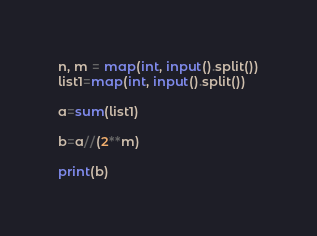<code> <loc_0><loc_0><loc_500><loc_500><_Python_>n, m = map(int, input().split())
list1=map(int, input().split())

a=sum(list1)

b=a//(2**m)

print(b)</code> 